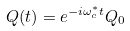<formula> <loc_0><loc_0><loc_500><loc_500>Q ( t ) = e ^ { - i \omega _ { c } ^ { * } t } Q _ { 0 }</formula> 